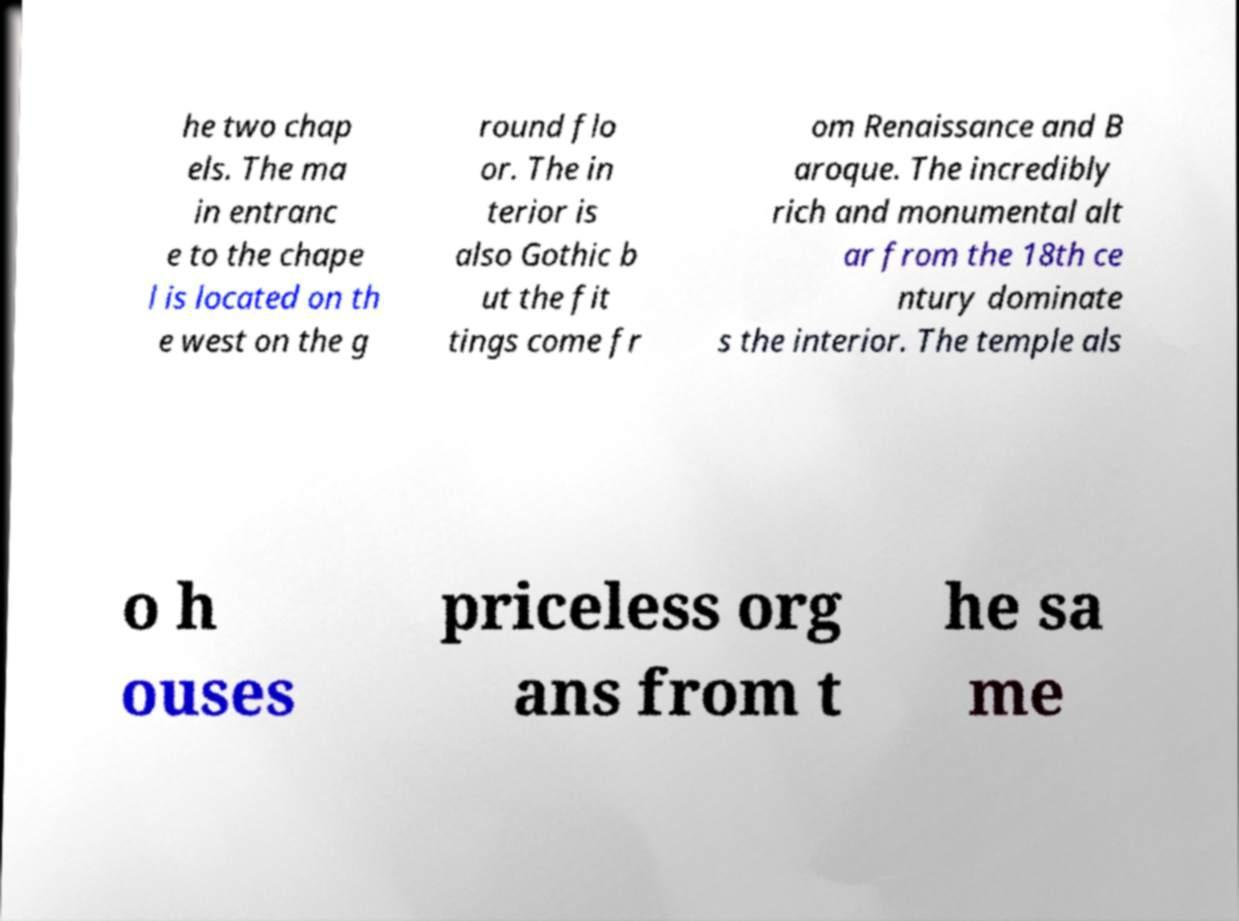What messages or text are displayed in this image? I need them in a readable, typed format. he two chap els. The ma in entranc e to the chape l is located on th e west on the g round flo or. The in terior is also Gothic b ut the fit tings come fr om Renaissance and B aroque. The incredibly rich and monumental alt ar from the 18th ce ntury dominate s the interior. The temple als o h ouses priceless org ans from t he sa me 